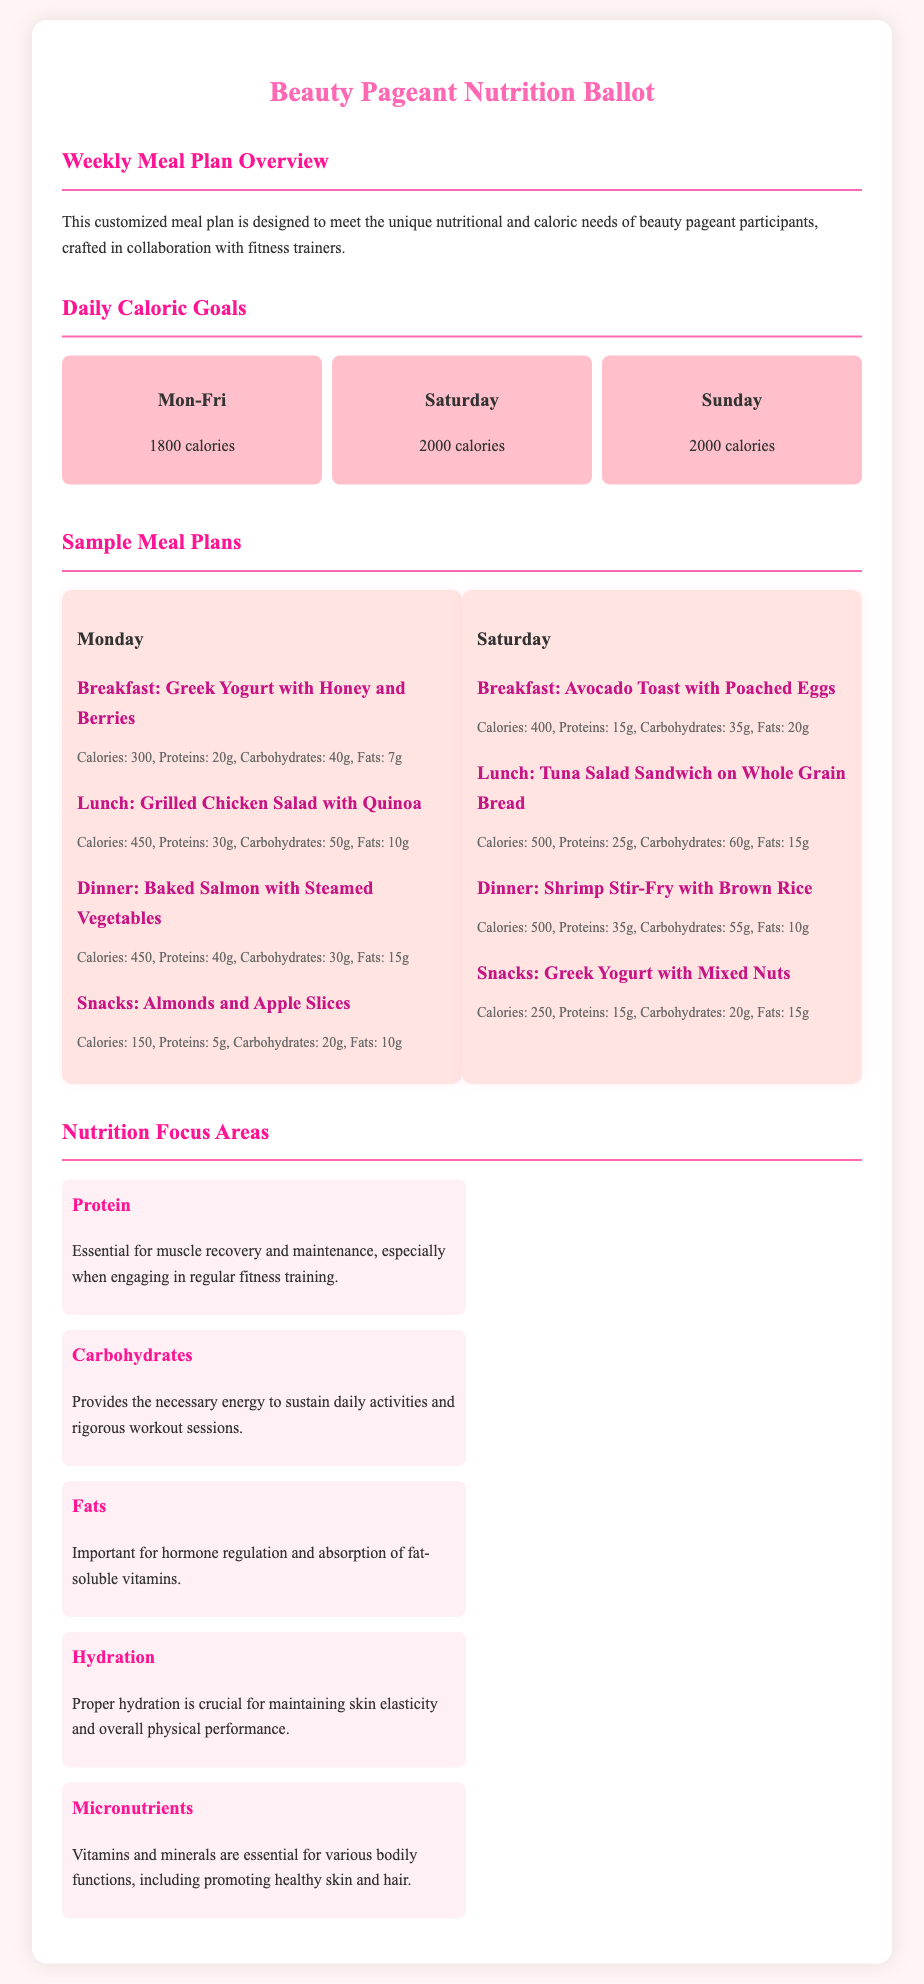What is the daily caloric goal for Monday to Friday? The document states that the daily caloric goal from Monday to Friday is 1800 calories.
Answer: 1800 calories How many grams of proteins are in the breakfast for Monday? The breakfast on Monday includes Greek Yogurt with Honey and Berries, which has 20 grams of proteins.
Answer: 20g What meal has the highest calorie count on Saturday? The meal with the highest calorie count on Saturday is the Tuna Salad Sandwich on Whole Grain Bread, which has 500 calories.
Answer: 500 calories What is one of the focus areas mentioned in the meal plan? The document lists several focus areas, including Protein, Carbohydrates, Fats, Hydration, and Micronutrients.
Answer: Protein How many meals are listed for Monday? The meal plan includes four meals listed for Monday: breakfast, lunch, dinner, and snacks.
Answer: Four meals What is the calorie content of the dinner on Monday? The dinner on Monday, which includes Baked Salmon with Steamed Vegetables, has 450 calories.
Answer: 450 calories What type of document is this? This document is a nutrition ballot specifically designed for beauty pageant participants.
Answer: Nutrition ballot What are the caloric goals for Sunday? The document specifies that the caloric goal for Sunday is 2000 calories.
Answer: 2000 calories 